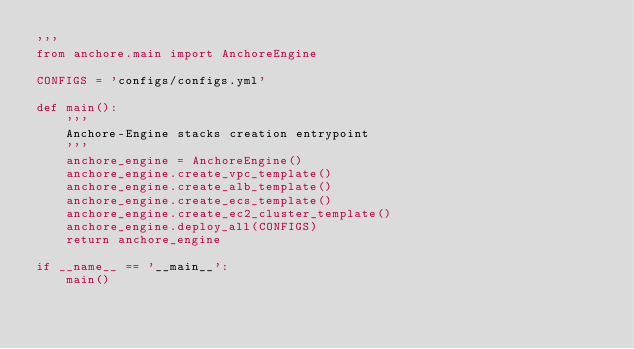Convert code to text. <code><loc_0><loc_0><loc_500><loc_500><_Python_>'''
from anchore.main import AnchoreEngine

CONFIGS = 'configs/configs.yml'

def main():
    '''
    Anchore-Engine stacks creation entrypoint
    '''
    anchore_engine = AnchoreEngine()
    anchore_engine.create_vpc_template()
    anchore_engine.create_alb_template()
    anchore_engine.create_ecs_template()
    anchore_engine.create_ec2_cluster_template()
    anchore_engine.deploy_all(CONFIGS)
    return anchore_engine

if __name__ == '__main__':
    main()
</code> 